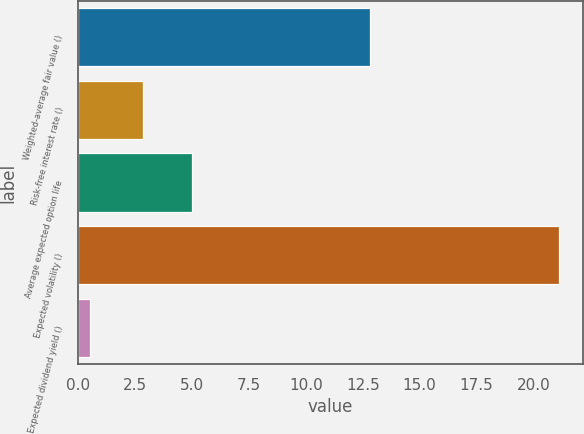Convert chart. <chart><loc_0><loc_0><loc_500><loc_500><bar_chart><fcel>Weighted-average fair value ()<fcel>Risk-free interest rate ()<fcel>Average expected option life<fcel>Expected volatility ()<fcel>Expected dividend yield ()<nl><fcel>12.83<fcel>2.87<fcel>5.02<fcel>21.1<fcel>0.53<nl></chart> 